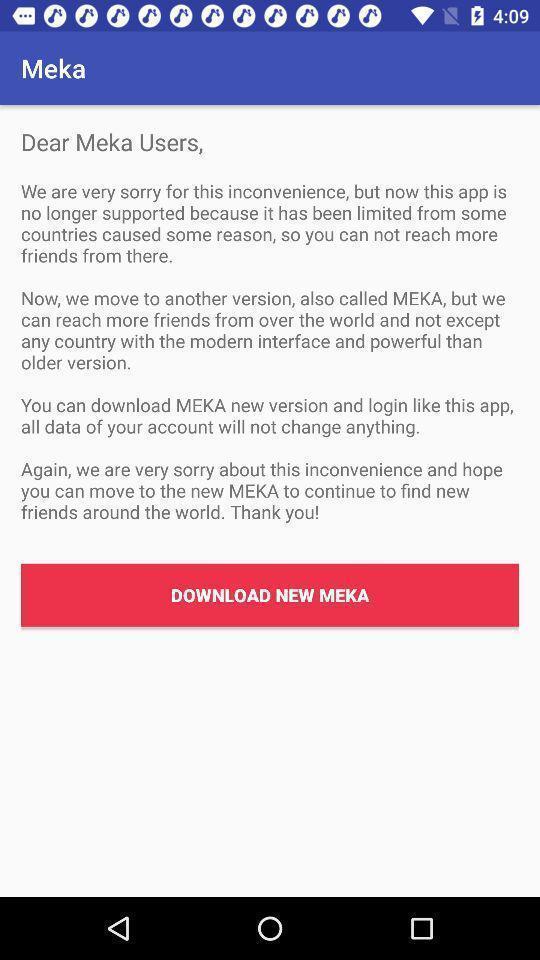Describe this image in words. Screen showing an option to download application. 